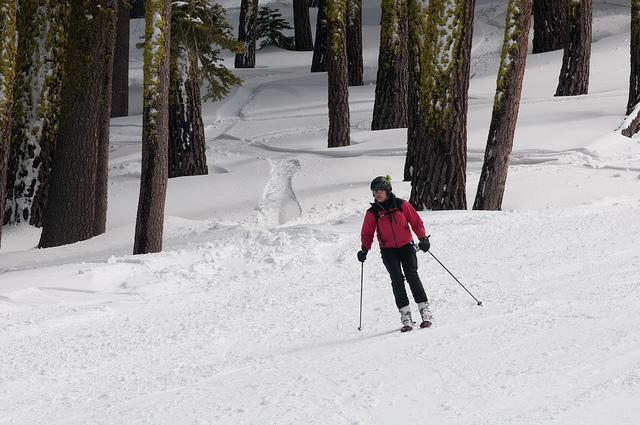How many headlights does this truck have?
Give a very brief answer. 0. 